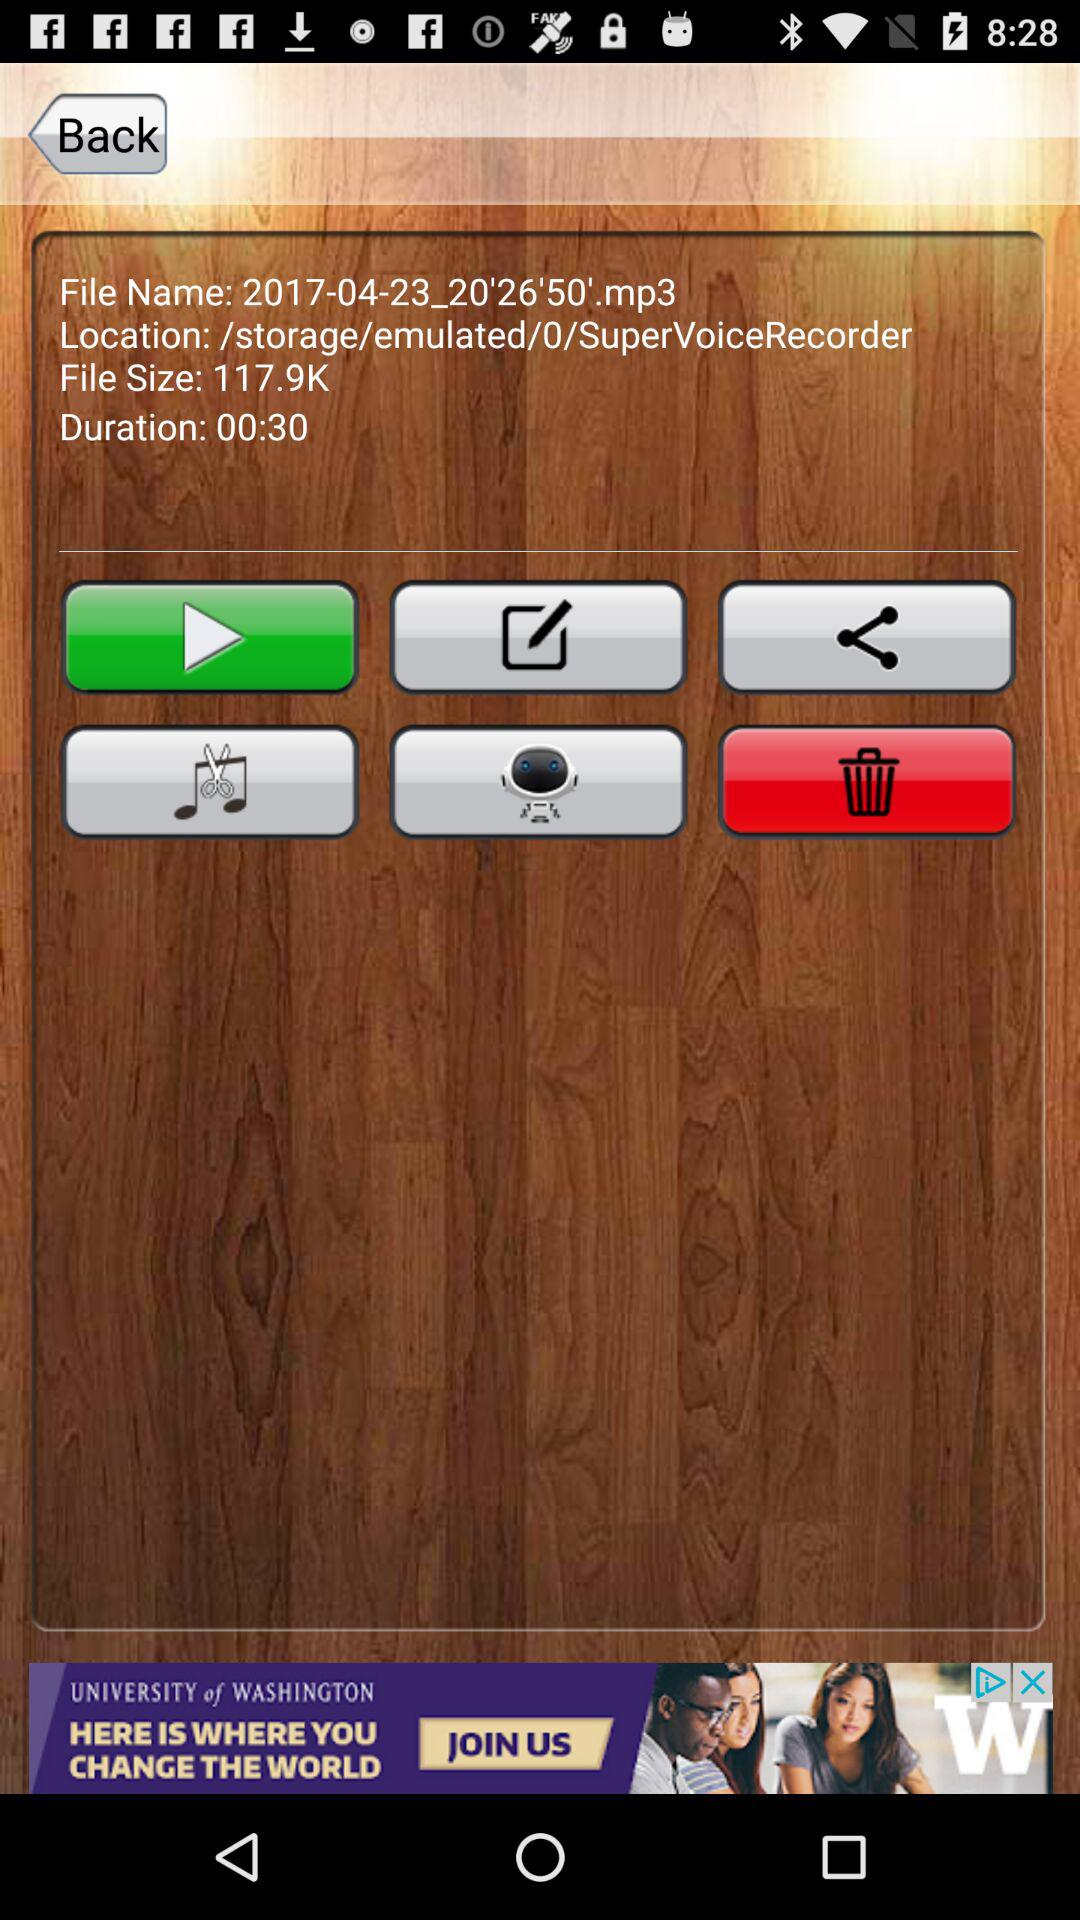What is the time duration? The time duration is 30 seconds. 